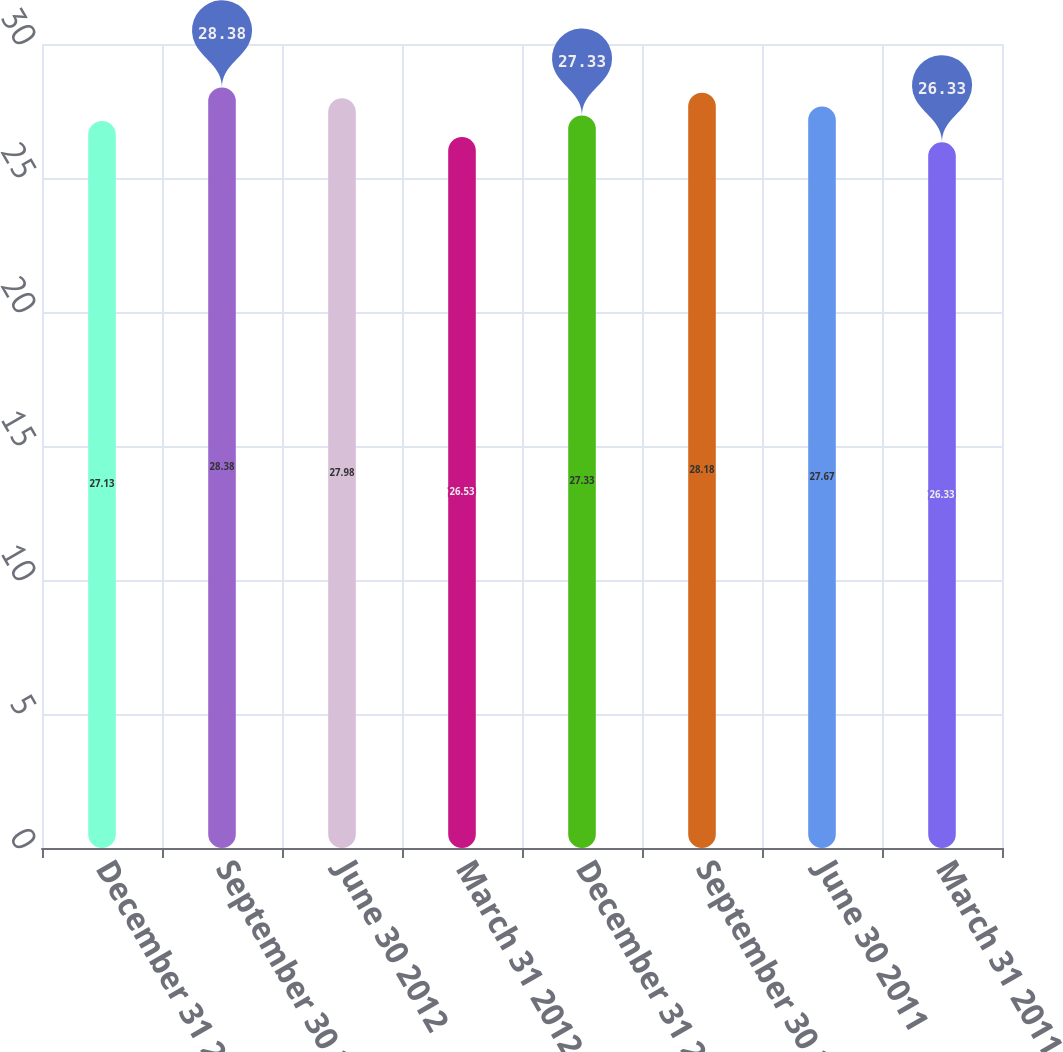Convert chart. <chart><loc_0><loc_0><loc_500><loc_500><bar_chart><fcel>December 31 2012<fcel>September 30 2012<fcel>June 30 2012<fcel>March 31 2012<fcel>December 31 2011<fcel>September 30 2011<fcel>June 30 2011<fcel>March 31 2011<nl><fcel>27.13<fcel>28.38<fcel>27.98<fcel>26.53<fcel>27.33<fcel>28.18<fcel>27.67<fcel>26.33<nl></chart> 